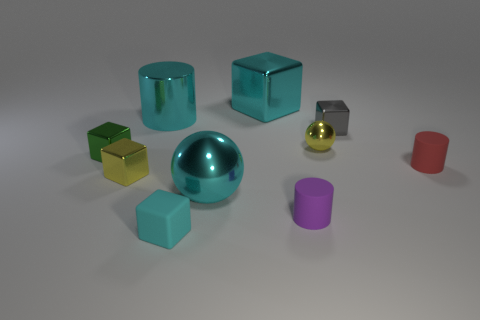The matte cylinder in front of the small yellow object that is in front of the tiny matte cylinder that is behind the tiny yellow metal block is what color?
Your answer should be compact. Purple. There is a tiny purple rubber thing in front of the small green cube; is there a gray metal cube behind it?
Your response must be concise. Yes. Does the large thing to the left of the small cyan cube have the same color as the rubber thing on the left side of the big cyan ball?
Keep it short and to the point. Yes. How many red matte cylinders are the same size as the cyan ball?
Your answer should be compact. 0. Do the ball behind the green metallic thing and the large cyan shiny sphere have the same size?
Your answer should be compact. No. What is the shape of the small gray shiny thing?
Make the answer very short. Cube. What is the size of the shiny ball that is the same color as the big metallic cylinder?
Provide a succinct answer. Large. Are the small yellow object that is right of the large metallic cylinder and the small green block made of the same material?
Offer a terse response. Yes. Is there a large metal block of the same color as the rubber block?
Your answer should be compact. Yes. There is a small yellow metallic object that is behind the small green metallic thing; is it the same shape as the small object in front of the small purple rubber thing?
Provide a succinct answer. No. 